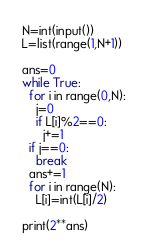Convert code to text. <code><loc_0><loc_0><loc_500><loc_500><_Python_>N=int(input())
L=list(range(1,N+1))

ans=0
while True:
  for i in range(0,N):
    j=0
    if L[i]%2==0:
      j+=1
  if j==0:
    break
  ans+=1
  for i in range(N):
    L[i]=int(L[i]/2)

print(2**ans)</code> 